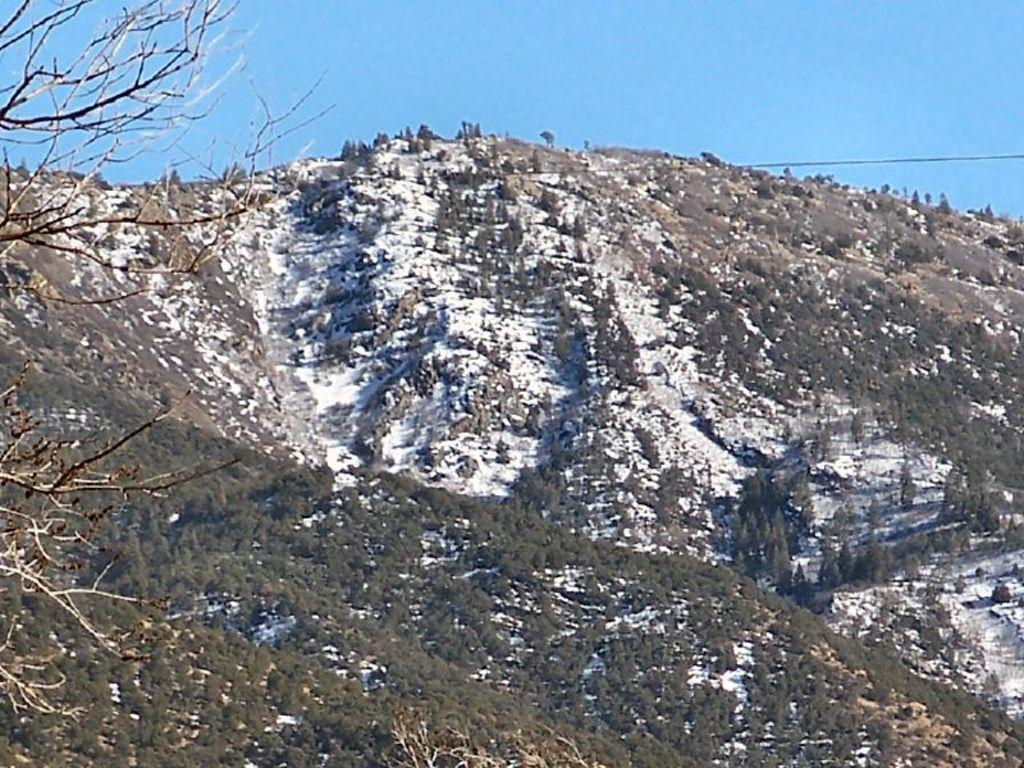What type of geographical feature is present in the image? There is a mountain in the image. What type of vegetation can be seen in the image? There are trees in the image. What is the weather like in the image? There is snow visible in the image, indicating cold weather. What else can be seen in the image besides the mountain and trees? The sky is visible in the image. Where is the prison located in the image? There is no prison present in the image. What type of metal is used to construct the mountain in the image? The mountain is a natural geographical feature and is not constructed with metal. 